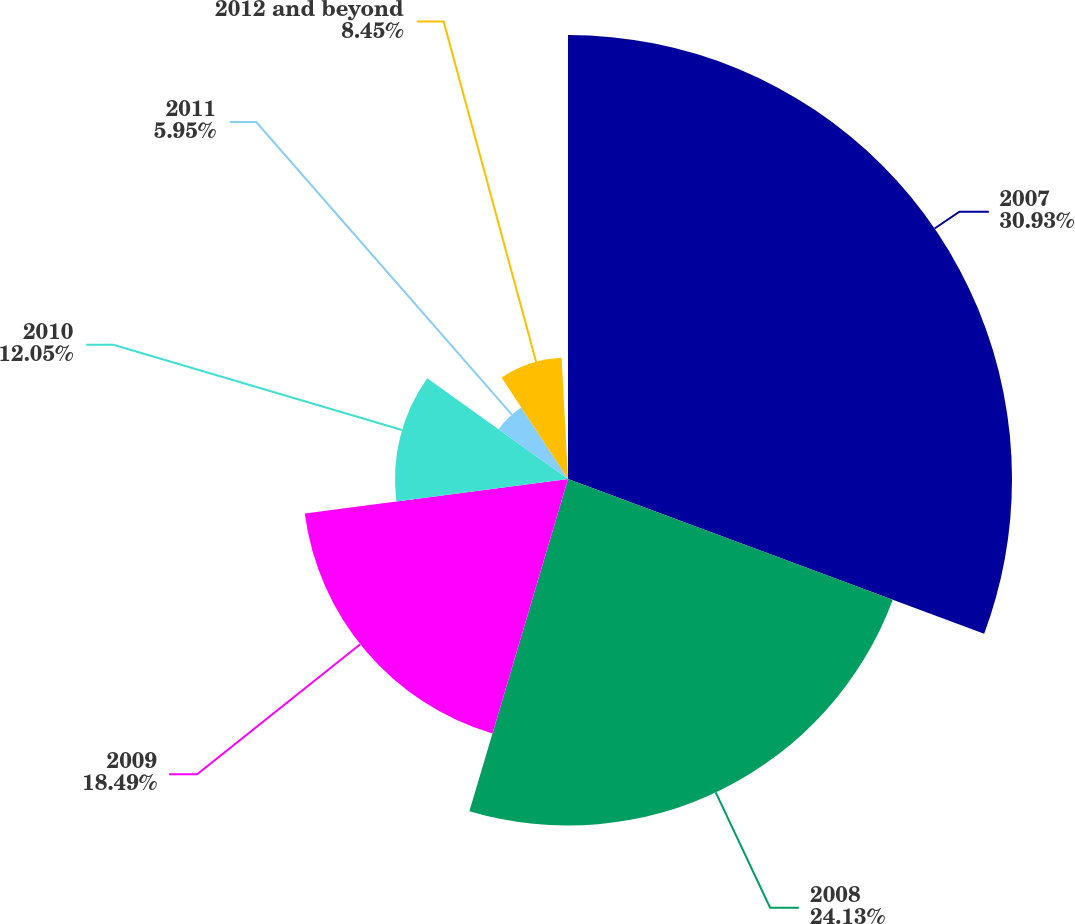<chart> <loc_0><loc_0><loc_500><loc_500><pie_chart><fcel>2007<fcel>2008<fcel>2009<fcel>2010<fcel>2011<fcel>2012 and beyond<nl><fcel>30.92%<fcel>24.13%<fcel>18.49%<fcel>12.05%<fcel>5.95%<fcel>8.45%<nl></chart> 